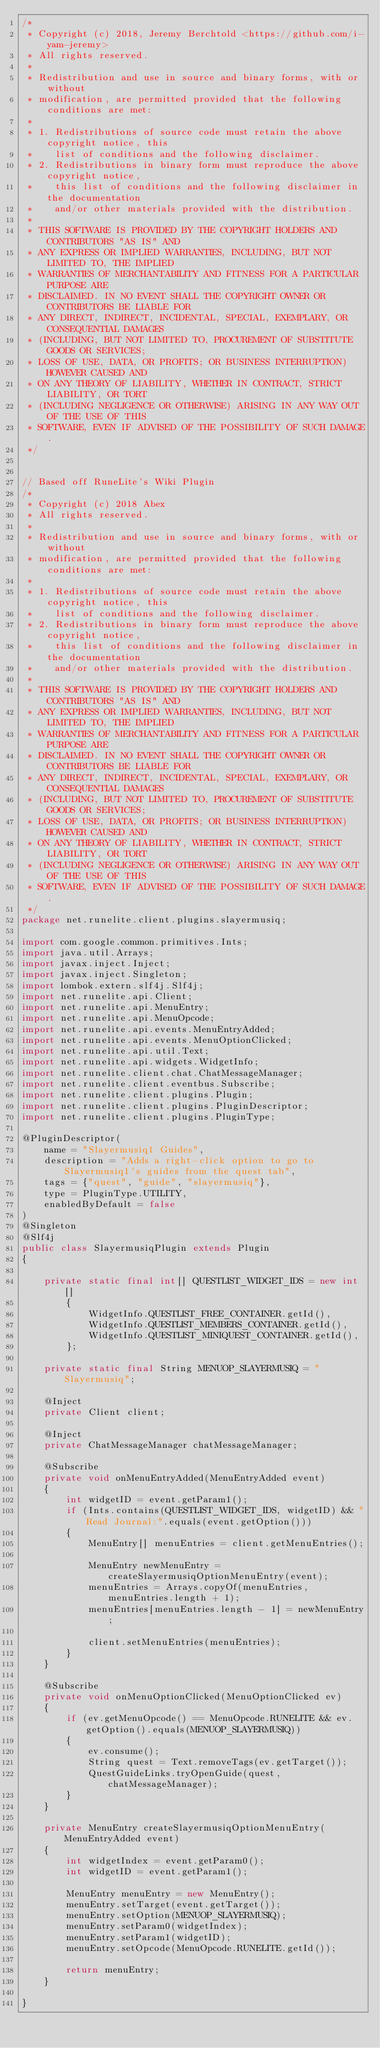Convert code to text. <code><loc_0><loc_0><loc_500><loc_500><_Java_>/*
 * Copyright (c) 2018, Jeremy Berchtold <https://github.com/i-yam-jeremy>
 * All rights reserved.
 *
 * Redistribution and use in source and binary forms, with or without
 * modification, are permitted provided that the following conditions are met:
 *
 * 1. Redistributions of source code must retain the above copyright notice, this
 *    list of conditions and the following disclaimer.
 * 2. Redistributions in binary form must reproduce the above copyright notice,
 *    this list of conditions and the following disclaimer in the documentation
 *    and/or other materials provided with the distribution.
 *
 * THIS SOFTWARE IS PROVIDED BY THE COPYRIGHT HOLDERS AND CONTRIBUTORS "AS IS" AND
 * ANY EXPRESS OR IMPLIED WARRANTIES, INCLUDING, BUT NOT LIMITED TO, THE IMPLIED
 * WARRANTIES OF MERCHANTABILITY AND FITNESS FOR A PARTICULAR PURPOSE ARE
 * DISCLAIMED. IN NO EVENT SHALL THE COPYRIGHT OWNER OR CONTRIBUTORS BE LIABLE FOR
 * ANY DIRECT, INDIRECT, INCIDENTAL, SPECIAL, EXEMPLARY, OR CONSEQUENTIAL DAMAGES
 * (INCLUDING, BUT NOT LIMITED TO, PROCUREMENT OF SUBSTITUTE GOODS OR SERVICES;
 * LOSS OF USE, DATA, OR PROFITS; OR BUSINESS INTERRUPTION) HOWEVER CAUSED AND
 * ON ANY THEORY OF LIABILITY, WHETHER IN CONTRACT, STRICT LIABILITY, OR TORT
 * (INCLUDING NEGLIGENCE OR OTHERWISE) ARISING IN ANY WAY OUT OF THE USE OF THIS
 * SOFTWARE, EVEN IF ADVISED OF THE POSSIBILITY OF SUCH DAMAGE.
 */


// Based off RuneLite's Wiki Plugin
/*
 * Copyright (c) 2018 Abex
 * All rights reserved.
 *
 * Redistribution and use in source and binary forms, with or without
 * modification, are permitted provided that the following conditions are met:
 *
 * 1. Redistributions of source code must retain the above copyright notice, this
 *    list of conditions and the following disclaimer.
 * 2. Redistributions in binary form must reproduce the above copyright notice,
 *    this list of conditions and the following disclaimer in the documentation
 *    and/or other materials provided with the distribution.
 *
 * THIS SOFTWARE IS PROVIDED BY THE COPYRIGHT HOLDERS AND CONTRIBUTORS "AS IS" AND
 * ANY EXPRESS OR IMPLIED WARRANTIES, INCLUDING, BUT NOT LIMITED TO, THE IMPLIED
 * WARRANTIES OF MERCHANTABILITY AND FITNESS FOR A PARTICULAR PURPOSE ARE
 * DISCLAIMED. IN NO EVENT SHALL THE COPYRIGHT OWNER OR CONTRIBUTORS BE LIABLE FOR
 * ANY DIRECT, INDIRECT, INCIDENTAL, SPECIAL, EXEMPLARY, OR CONSEQUENTIAL DAMAGES
 * (INCLUDING, BUT NOT LIMITED TO, PROCUREMENT OF SUBSTITUTE GOODS OR SERVICES;
 * LOSS OF USE, DATA, OR PROFITS; OR BUSINESS INTERRUPTION) HOWEVER CAUSED AND
 * ON ANY THEORY OF LIABILITY, WHETHER IN CONTRACT, STRICT LIABILITY, OR TORT
 * (INCLUDING NEGLIGENCE OR OTHERWISE) ARISING IN ANY WAY OUT OF THE USE OF THIS
 * SOFTWARE, EVEN IF ADVISED OF THE POSSIBILITY OF SUCH DAMAGE.
 */
package net.runelite.client.plugins.slayermusiq;

import com.google.common.primitives.Ints;
import java.util.Arrays;
import javax.inject.Inject;
import javax.inject.Singleton;
import lombok.extern.slf4j.Slf4j;
import net.runelite.api.Client;
import net.runelite.api.MenuEntry;
import net.runelite.api.MenuOpcode;
import net.runelite.api.events.MenuEntryAdded;
import net.runelite.api.events.MenuOptionClicked;
import net.runelite.api.util.Text;
import net.runelite.api.widgets.WidgetInfo;
import net.runelite.client.chat.ChatMessageManager;
import net.runelite.client.eventbus.Subscribe;
import net.runelite.client.plugins.Plugin;
import net.runelite.client.plugins.PluginDescriptor;
import net.runelite.client.plugins.PluginType;

@PluginDescriptor(
	name = "Slayermusiq1 Guides",
	description = "Adds a right-click option to go to Slayermusiq1's guides from the quest tab",
	tags = {"quest", "guide", "slayermusiq"},
	type = PluginType.UTILITY,
	enabledByDefault = false
)
@Singleton
@Slf4j
public class SlayermusiqPlugin extends Plugin
{

	private static final int[] QUESTLIST_WIDGET_IDS = new int[]
		{
			WidgetInfo.QUESTLIST_FREE_CONTAINER.getId(),
			WidgetInfo.QUESTLIST_MEMBERS_CONTAINER.getId(),
			WidgetInfo.QUESTLIST_MINIQUEST_CONTAINER.getId(),
		};

	private static final String MENUOP_SLAYERMUSIQ = "Slayermusiq";

	@Inject
	private Client client;

	@Inject
	private ChatMessageManager chatMessageManager;

	@Subscribe
	private void onMenuEntryAdded(MenuEntryAdded event)
	{
		int widgetID = event.getParam1();
		if (Ints.contains(QUESTLIST_WIDGET_IDS, widgetID) && "Read Journal:".equals(event.getOption()))
		{
			MenuEntry[] menuEntries = client.getMenuEntries();

			MenuEntry newMenuEntry = createSlayermusiqOptionMenuEntry(event);
			menuEntries = Arrays.copyOf(menuEntries, menuEntries.length + 1);
			menuEntries[menuEntries.length - 1] = newMenuEntry;

			client.setMenuEntries(menuEntries);
		}
	}

	@Subscribe
	private void onMenuOptionClicked(MenuOptionClicked ev)
	{
		if (ev.getMenuOpcode() == MenuOpcode.RUNELITE && ev.getOption().equals(MENUOP_SLAYERMUSIQ))
		{
			ev.consume();
			String quest = Text.removeTags(ev.getTarget());
			QuestGuideLinks.tryOpenGuide(quest, chatMessageManager);
		}
	}

	private MenuEntry createSlayermusiqOptionMenuEntry(MenuEntryAdded event)
	{
		int widgetIndex = event.getParam0();
		int widgetID = event.getParam1();

		MenuEntry menuEntry = new MenuEntry();
		menuEntry.setTarget(event.getTarget());
		menuEntry.setOption(MENUOP_SLAYERMUSIQ);
		menuEntry.setParam0(widgetIndex);
		menuEntry.setParam1(widgetID);
		menuEntry.setOpcode(MenuOpcode.RUNELITE.getId());

		return menuEntry;
	}

}</code> 